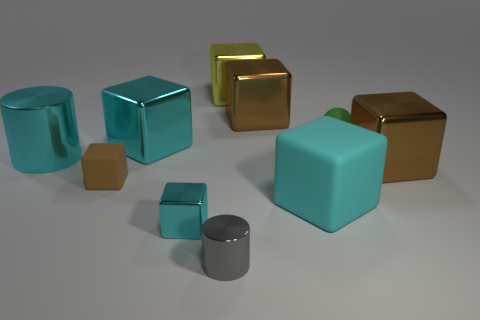What number of cyan things are there?
Your answer should be very brief. 4. Does the large matte block have the same color as the metal cylinder that is left of the tiny cyan cube?
Keep it short and to the point. Yes. Are there more purple objects than cyan metallic cubes?
Keep it short and to the point. No. Is there anything else that has the same color as the ball?
Make the answer very short. No. What number of other things are the same size as the cyan cylinder?
Give a very brief answer. 5. There is a brown thing that is behind the green rubber sphere on the left side of the big brown thing that is right of the matte sphere; what is it made of?
Offer a very short reply. Metal. Is the material of the big cyan cylinder the same as the big object in front of the tiny rubber block?
Your answer should be compact. No. Are there fewer brown shiny cubes that are in front of the tiny brown thing than big yellow cubes right of the cyan metal cylinder?
Your response must be concise. Yes. What number of yellow blocks are made of the same material as the gray cylinder?
Your response must be concise. 1. Are there any rubber objects to the left of the rubber object behind the cyan metallic block that is behind the big cylinder?
Give a very brief answer. Yes. 